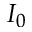Convert formula to latex. <formula><loc_0><loc_0><loc_500><loc_500>I _ { 0 }</formula> 